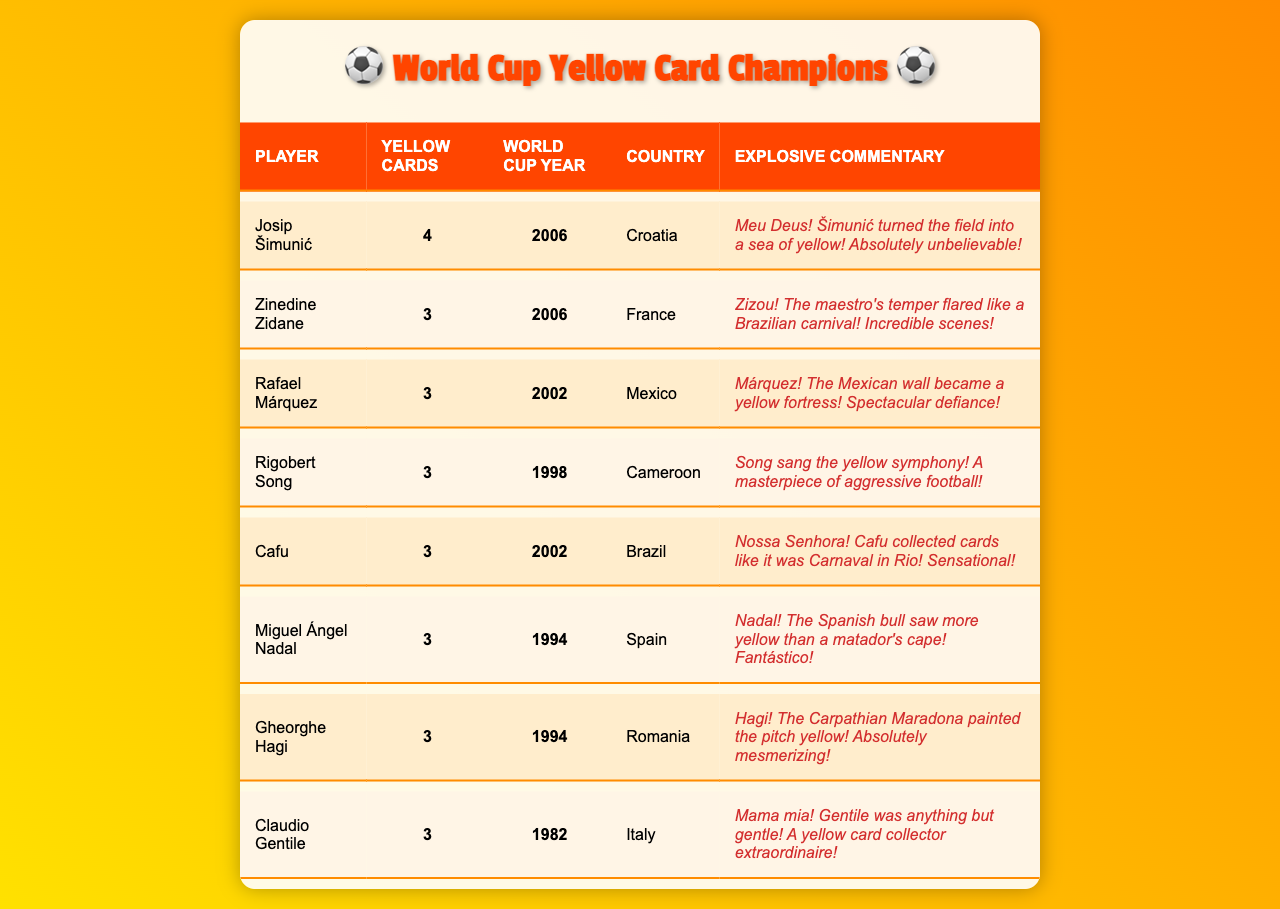What player received the most yellow cards in a single World Cup tournament? Josip Šimunić received the highest number of yellow cards, totaling 4 during the 2006 World Cup.
Answer: Josip Šimunić Which country did Zinedine Zidane represent when he received 3 yellow cards? Zidane represented France during the 2006 World Cup when he received his 3 yellow cards.
Answer: France How many players received exactly 3 yellow cards? There are 6 players listed who each received exactly 3 yellow cards.
Answer: 6 Did any player receive more than 3 yellow cards in the same tournament? Yes, Josip Šimunić is the only player who received more than 3 yellow cards with a total of 4.
Answer: Yes Which World Cup year had the highest number of players receiving 3 yellow cards? The 2006 World Cup had 2 players (Zinedine Zidane and Josip Šimunić) receiving yellow cards with three or more.
Answer: 2006 What is the average number of yellow cards received by the players in the table? To find the average, sum all yellow cards (4 + 3 + 3 + 3 + 3 + 3 + 3 + 3 = 23) and divide by the number of players (8), giving an average of 23/8 = 2.875.
Answer: 2.875 Are there any players from Brazil in the list? Yes, Cafu is the Brazilian player listed who received 3 yellow cards during the 2002 World Cup.
Answer: Yes Which player received yellow cards in the same World Cup as Rafael Márquez? Cafu and Rigobert Song received yellow cards in the 2002 World Cup alongside Rafael Márquez.
Answer: Cafu and Rigobert Song What was the total number of yellow cards issued to players from 1994? The total for players from 1994 (Nadal, Hagi) is 3 + 3 = 6 yellow cards.
Answer: 6 Who had the most explosive commentary and what was it? The most explosive commentary was about Josip Šimunić: "Meu Deus! Šimunić turned the field into a sea of yellow! Absolutely unbelievable!"
Answer: Josip Šimunić 